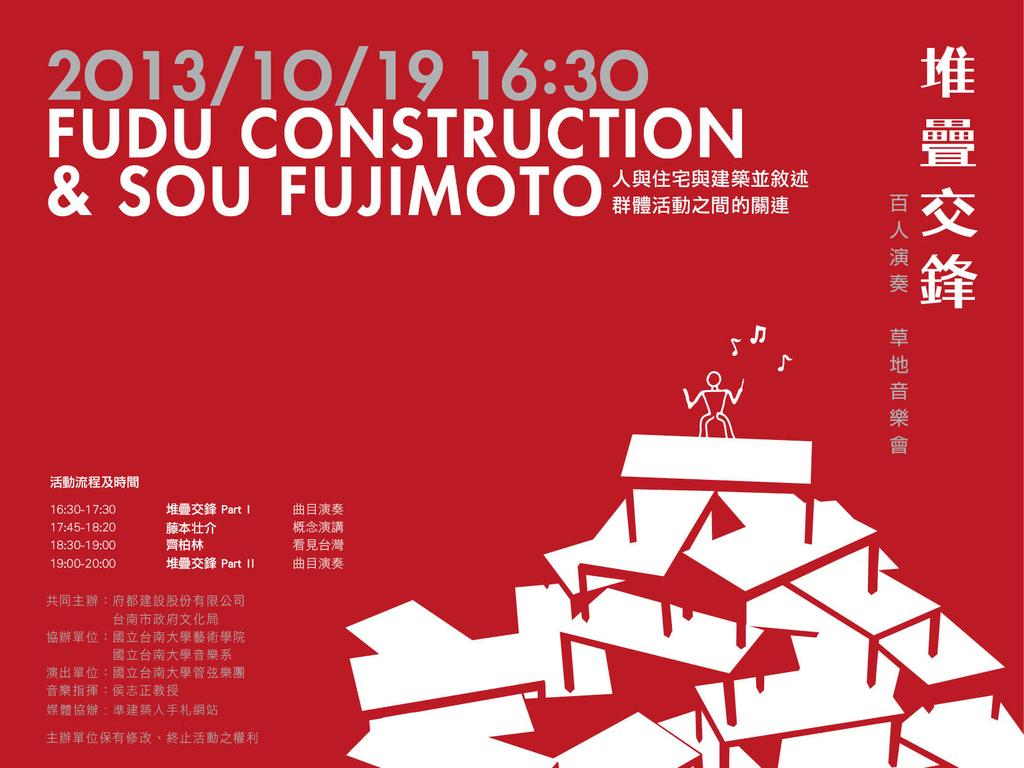Provide a one-sentence caption for the provided image. Fudu construction and sou fujimoto that is written in china. 